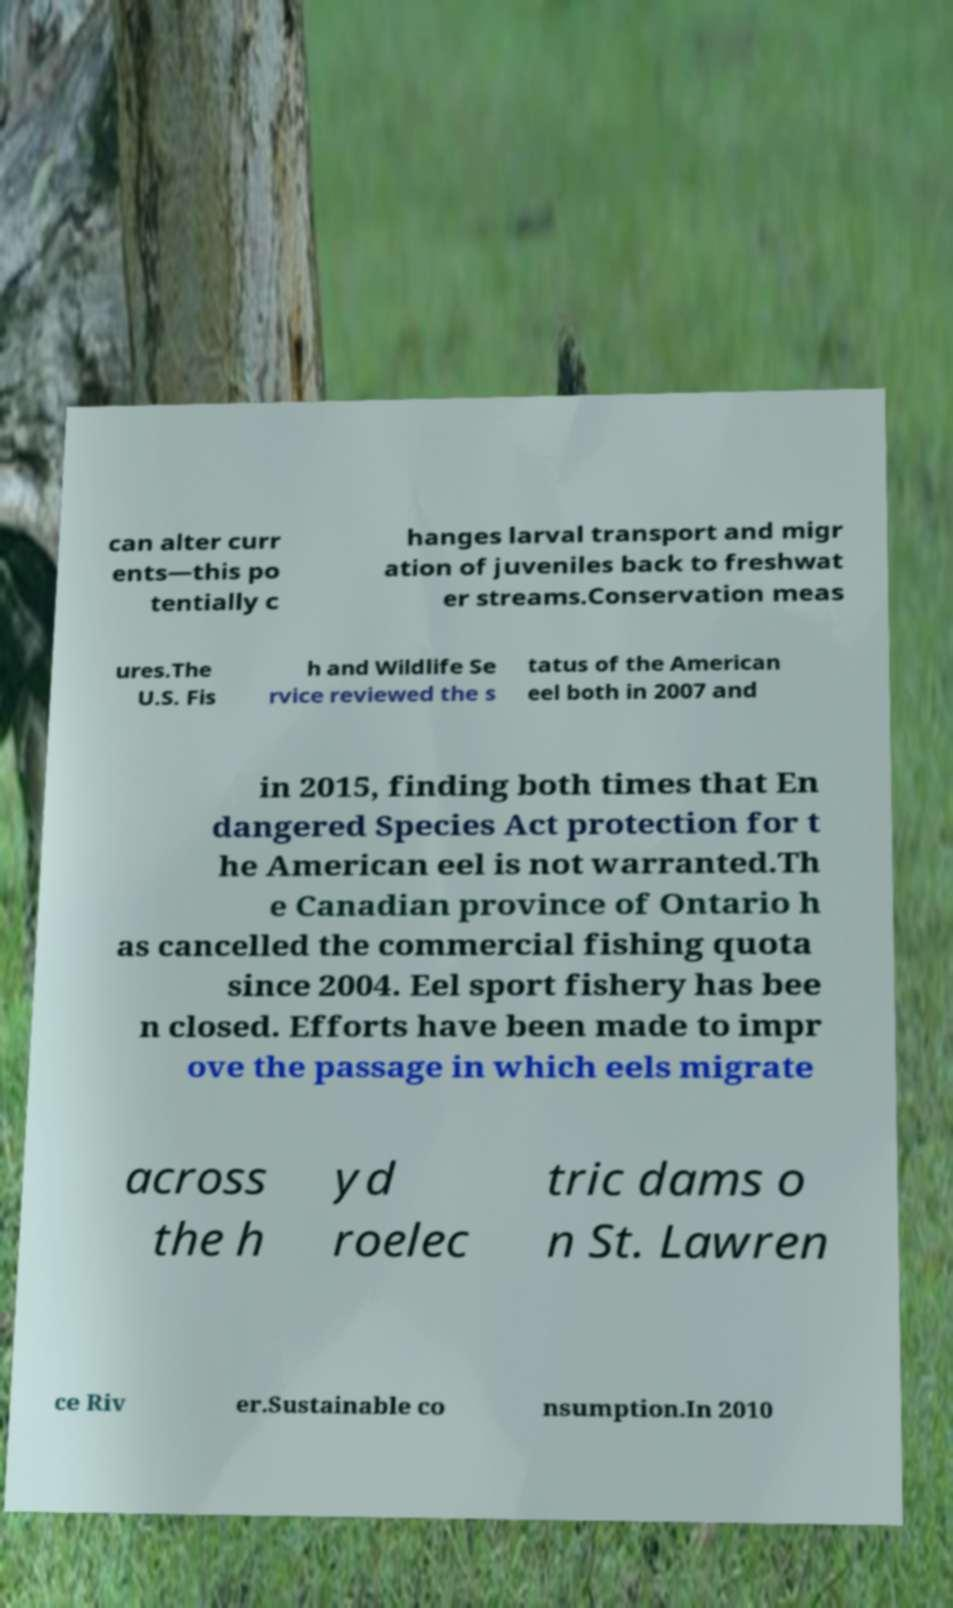For documentation purposes, I need the text within this image transcribed. Could you provide that? can alter curr ents—this po tentially c hanges larval transport and migr ation of juveniles back to freshwat er streams.Conservation meas ures.The U.S. Fis h and Wildlife Se rvice reviewed the s tatus of the American eel both in 2007 and in 2015, finding both times that En dangered Species Act protection for t he American eel is not warranted.Th e Canadian province of Ontario h as cancelled the commercial fishing quota since 2004. Eel sport fishery has bee n closed. Efforts have been made to impr ove the passage in which eels migrate across the h yd roelec tric dams o n St. Lawren ce Riv er.Sustainable co nsumption.In 2010 